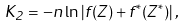Convert formula to latex. <formula><loc_0><loc_0><loc_500><loc_500>K _ { 2 } = - n \ln \left | f ( Z ) + f ^ { * } ( Z ^ { * } ) \right | ,</formula> 